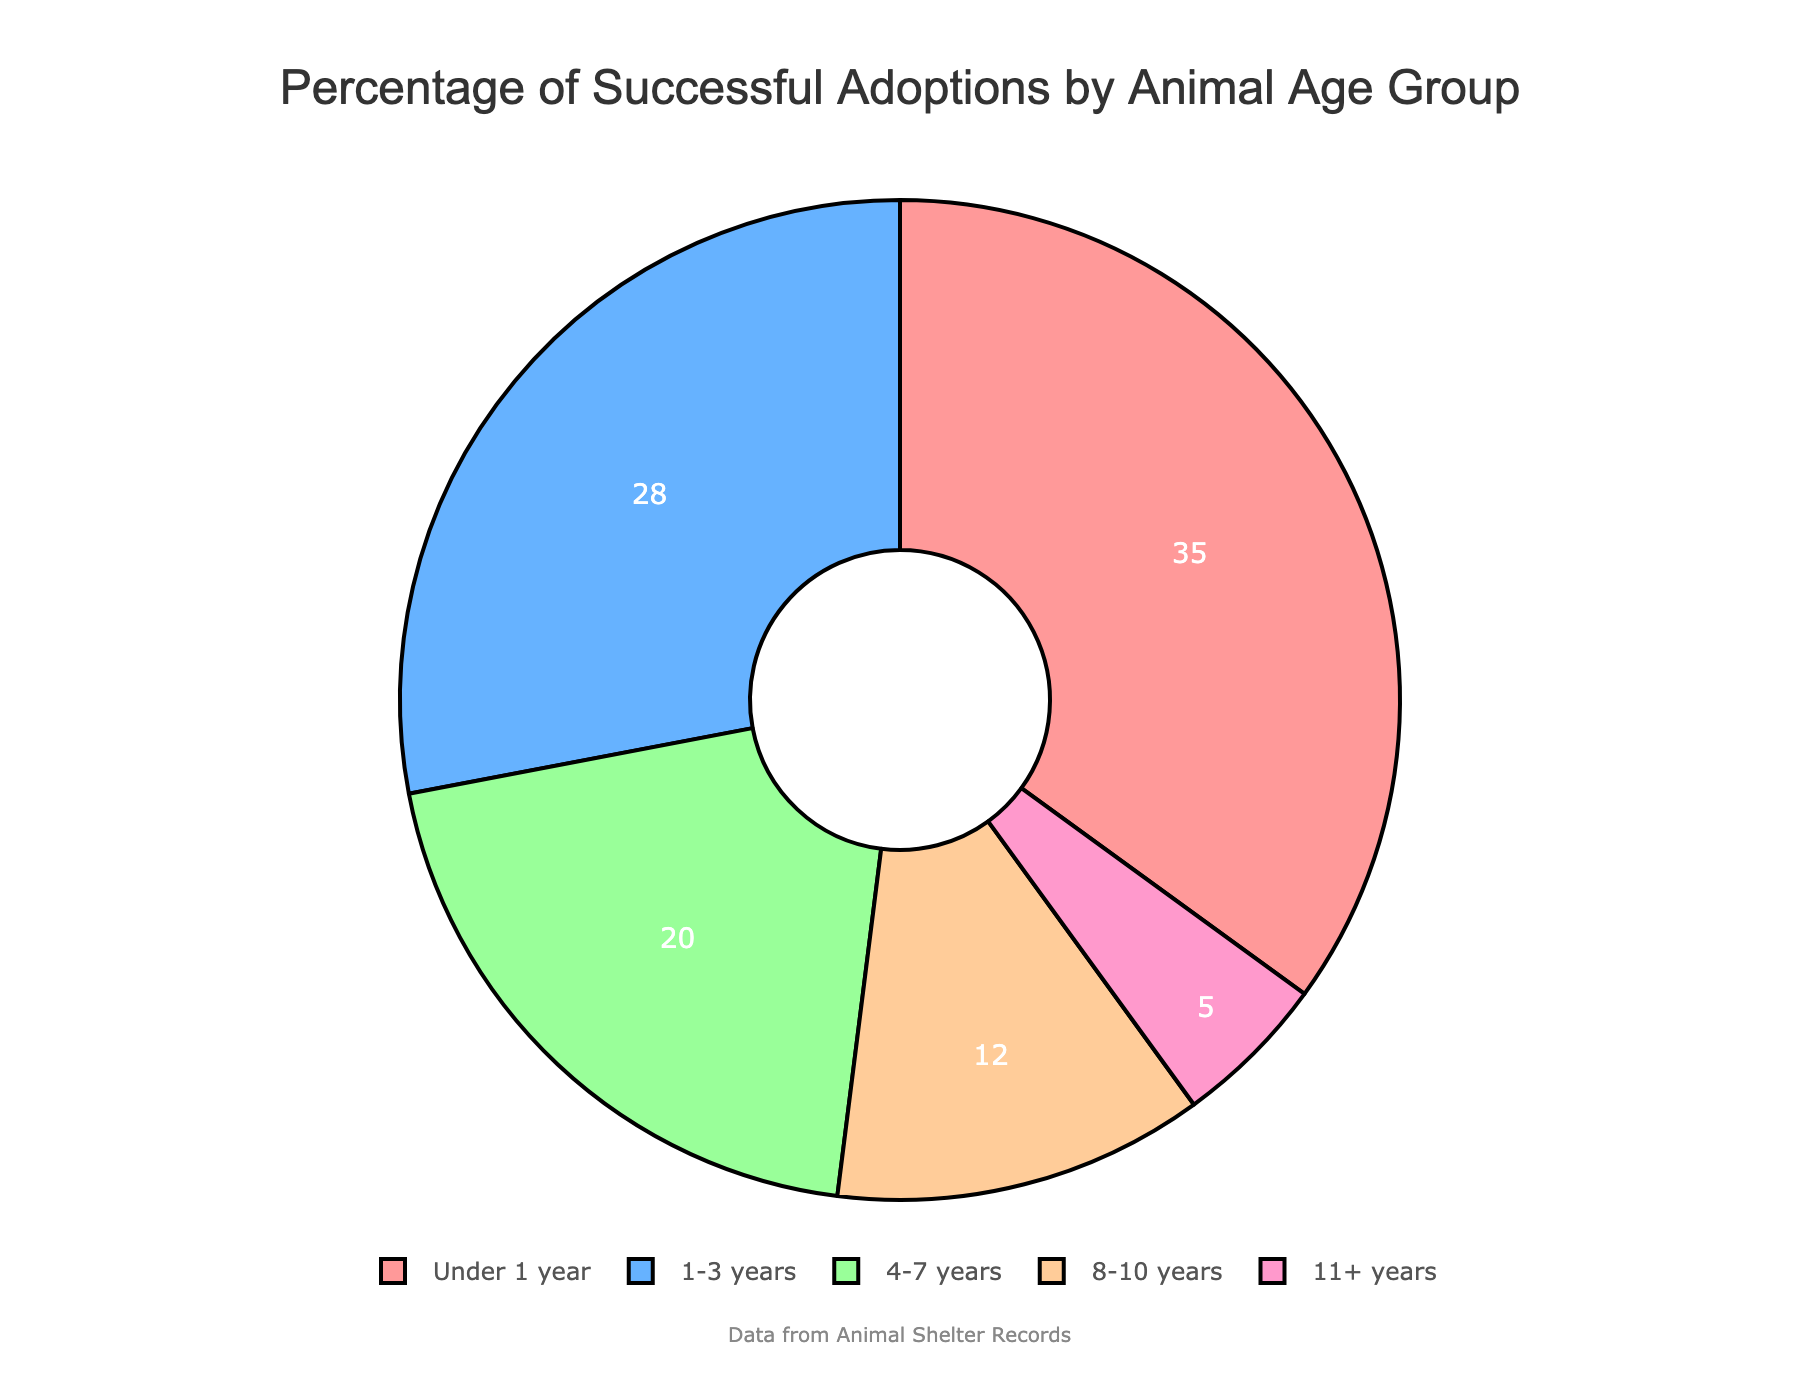What's the age group with the highest percentage of successful adoptions? The age group with the highest percentage is represented by the largest section of the pie chart, depicted in a particular color. The largest section color is light red, which corresponds to "Under 1 year" with 35%.
Answer: Under 1 year Which age group has the lowest percentage of successful adoptions? The age group with the lowest percentage is represented by the smallest section of the pie chart, depicted in a specific color. The smallest section color is light pink, which corresponds to "11+ years" with 5%.
Answer: 11+ years Is the percentage of successful adoptions for the "4-7 years" age group higher or lower than the "1-3 years" age group? By comparing the sizes of the pie chart sections, the "1-3 years" group has 28% and the "4-7 years" group has 20%. Thus, 20% is lower than 28%.
Answer: Lower What's the total percentage of successful adoptions for animals under 4 years old? Sum the percentages of the "Under 1 year" (35%) and "1-3 years" (28%) groups. 35% + 28% equals 63%.
Answer: 63% What is the difference in percentage between the "Under 1 year" and "8-10 years" age groups? Subtract the percentage of "8-10 years" (12%) from "Under 1 year" (35%). 35% - 12% equals 23%.
Answer: 23% What's the sum of the percentages of successful adoptions for animals aged 4 years or older? Add the percentages of the "4-7 years" (20%), "8-10 years" (12%), and "11+ years" (5%) groups. 20% + 12% + 5% equals 37%.
Answer: 37% Which age group is represented by the light blue color in the pie chart? Visual observation shows the light blue section is the second largest. This corresponds to the "1-3 years" group, which is 28%.
Answer: 1-3 years 